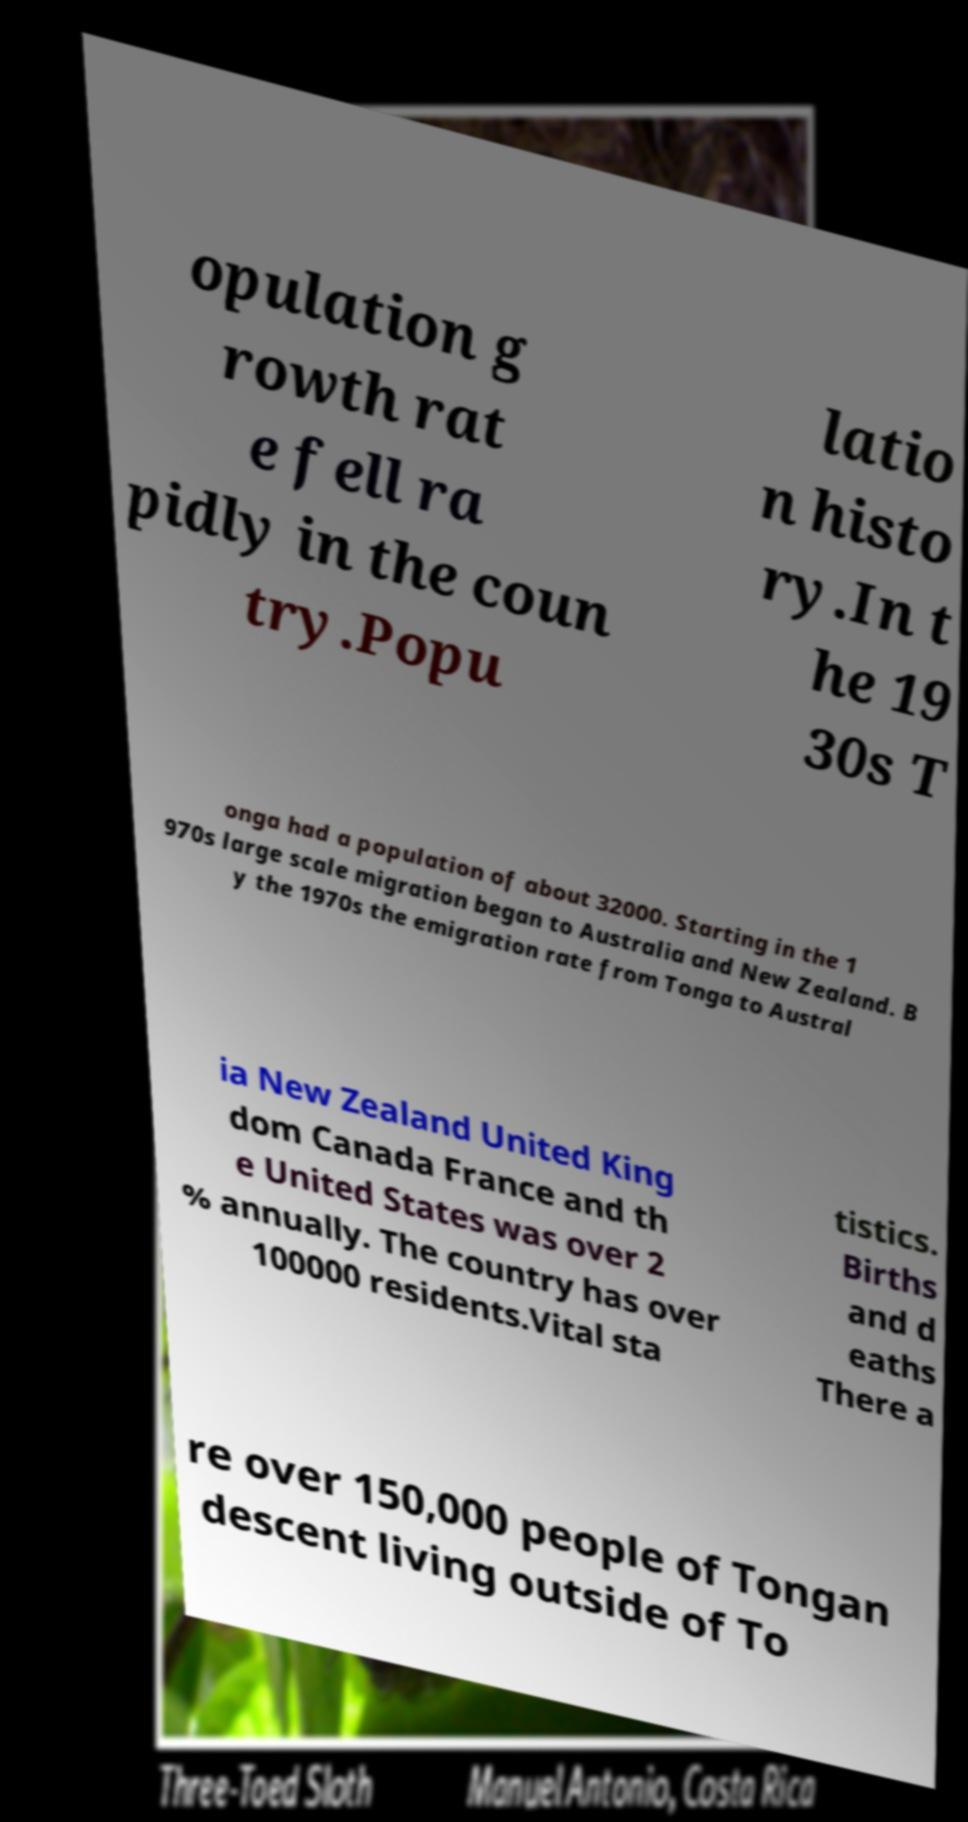Can you accurately transcribe the text from the provided image for me? opulation g rowth rat e fell ra pidly in the coun try.Popu latio n histo ry.In t he 19 30s T onga had a population of about 32000. Starting in the 1 970s large scale migration began to Australia and New Zealand. B y the 1970s the emigration rate from Tonga to Austral ia New Zealand United King dom Canada France and th e United States was over 2 % annually. The country has over 100000 residents.Vital sta tistics. Births and d eaths There a re over 150,000 people of Tongan descent living outside of To 